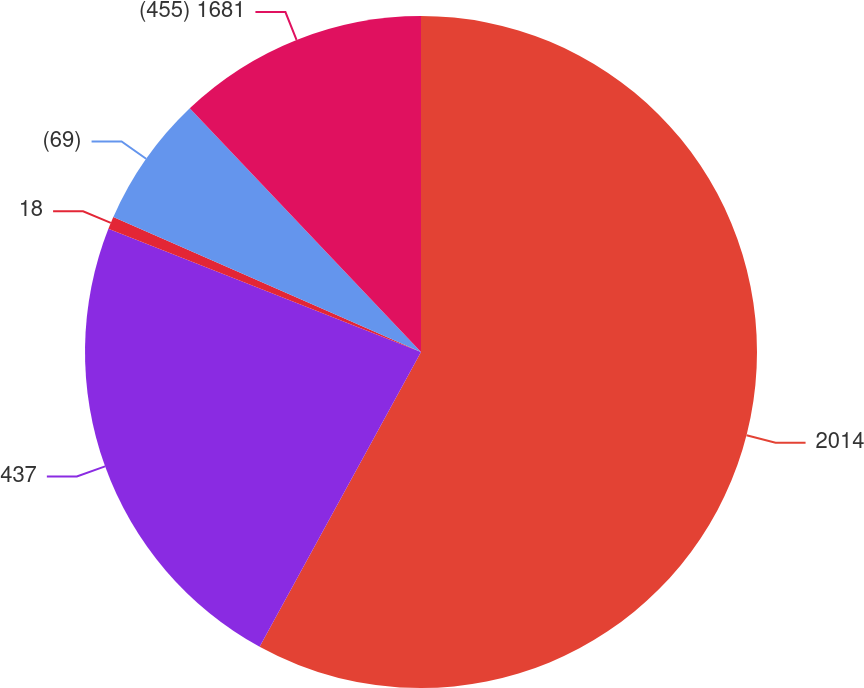Convert chart. <chart><loc_0><loc_0><loc_500><loc_500><pie_chart><fcel>2014<fcel>437<fcel>18<fcel>(69)<fcel>(455) 1681<nl><fcel>57.98%<fcel>23.0%<fcel>0.61%<fcel>6.34%<fcel>12.08%<nl></chart> 